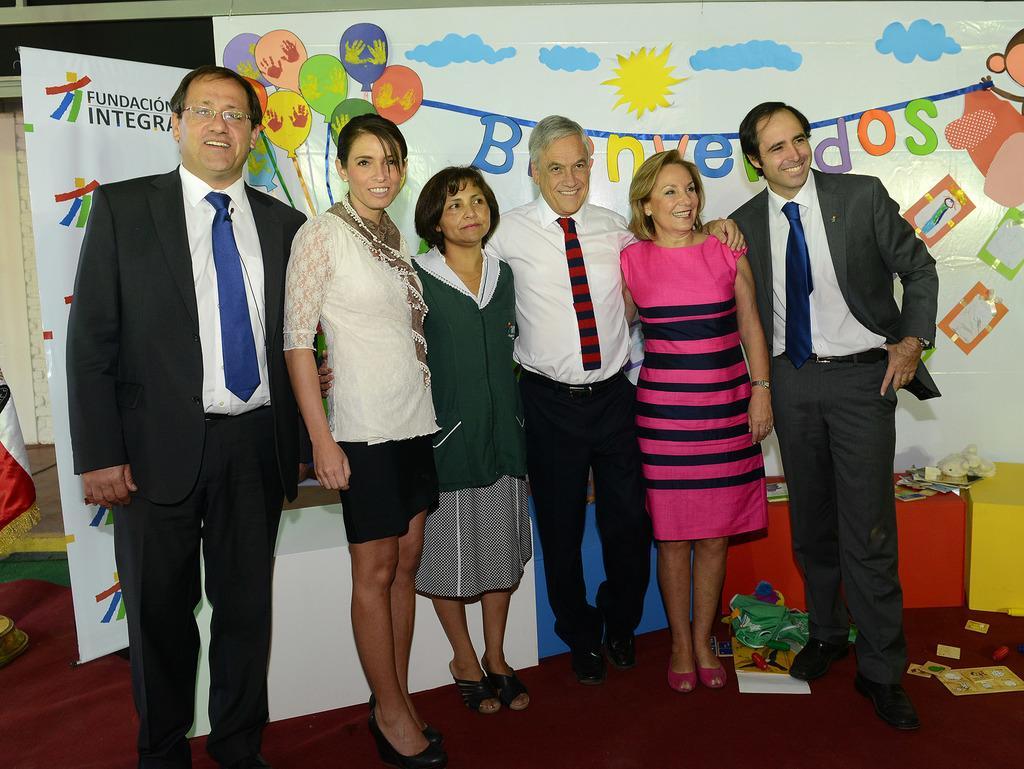Could you give a brief overview of what you see in this image? In this image we can see the people standing on the carpet and smiling. In the background, we can see the decorated banner. We can also see the papers and some other objects. On the left, we can see the banner with the text. 